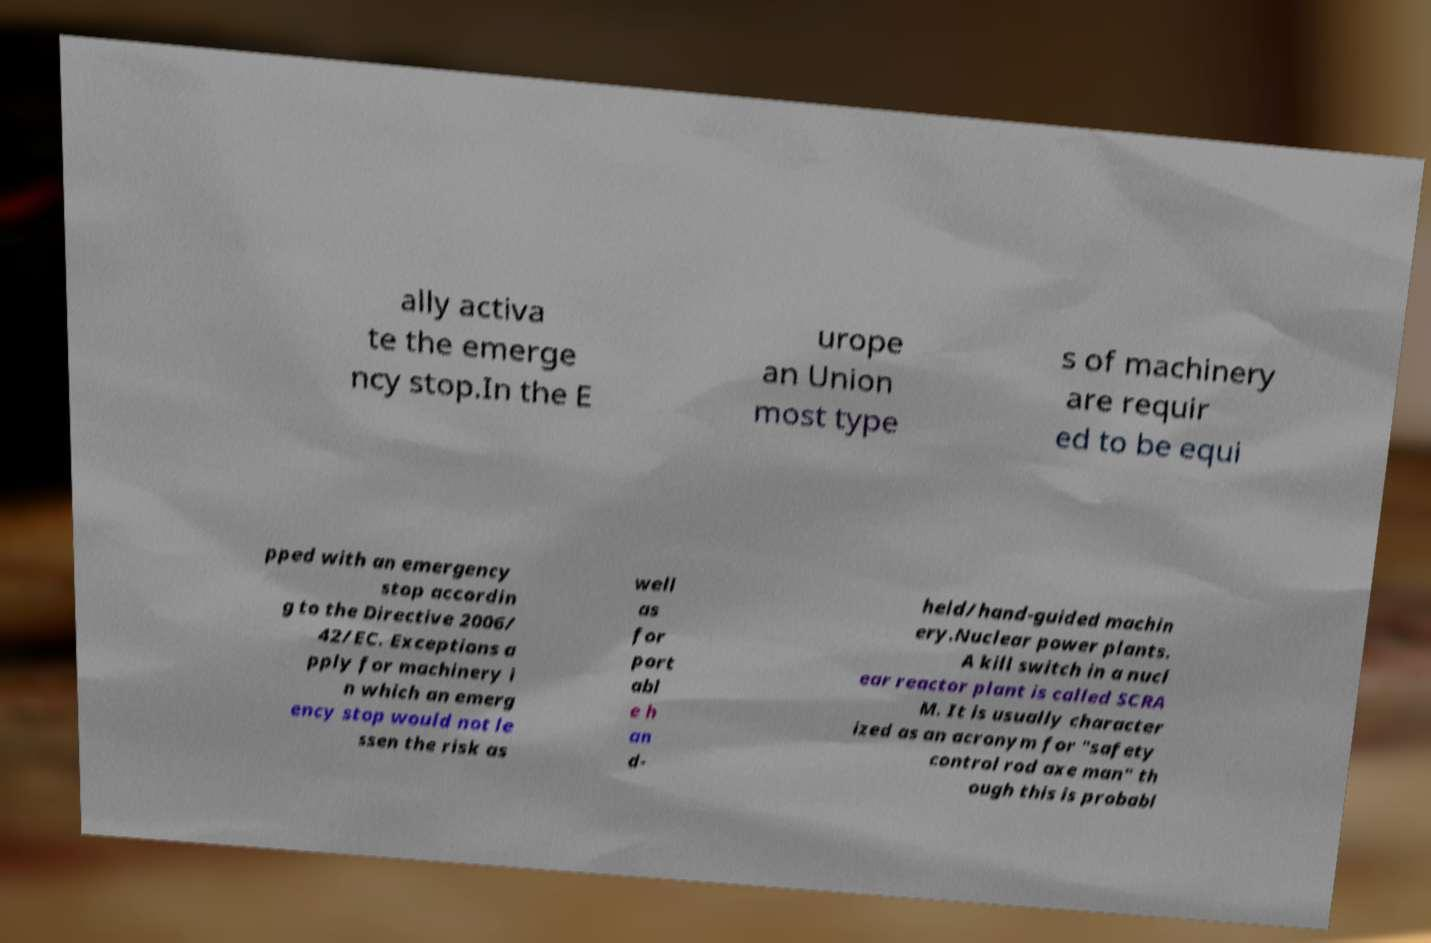There's text embedded in this image that I need extracted. Can you transcribe it verbatim? ally activa te the emerge ncy stop.In the E urope an Union most type s of machinery are requir ed to be equi pped with an emergency stop accordin g to the Directive 2006/ 42/EC. Exceptions a pply for machinery i n which an emerg ency stop would not le ssen the risk as well as for port abl e h an d- held/hand-guided machin ery.Nuclear power plants. A kill switch in a nucl ear reactor plant is called SCRA M. It is usually character ized as an acronym for "safety control rod axe man" th ough this is probabl 